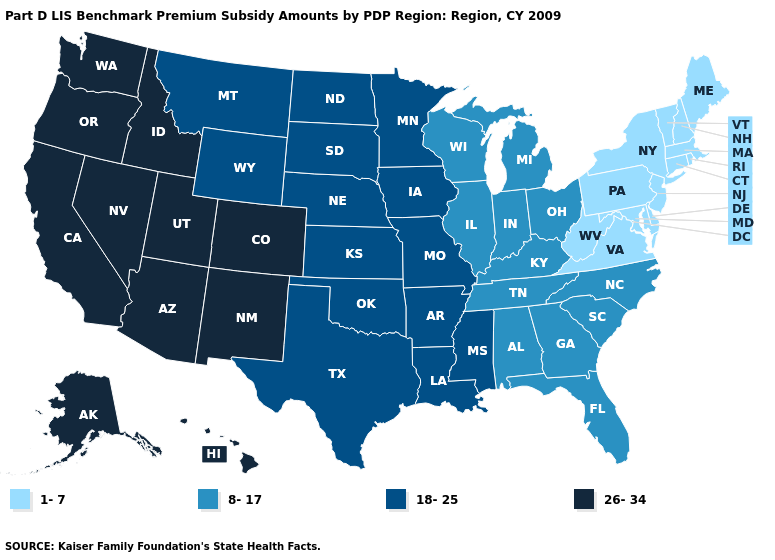Does Illinois have the same value as Utah?
Write a very short answer. No. What is the lowest value in the MidWest?
Keep it brief. 8-17. Does Maryland have the lowest value in the USA?
Concise answer only. Yes. What is the value of Texas?
Short answer required. 18-25. Does the map have missing data?
Be succinct. No. What is the value of Nebraska?
Give a very brief answer. 18-25. Name the states that have a value in the range 26-34?
Answer briefly. Alaska, Arizona, California, Colorado, Hawaii, Idaho, Nevada, New Mexico, Oregon, Utah, Washington. How many symbols are there in the legend?
Concise answer only. 4. Name the states that have a value in the range 26-34?
Answer briefly. Alaska, Arizona, California, Colorado, Hawaii, Idaho, Nevada, New Mexico, Oregon, Utah, Washington. Does Delaware have the lowest value in the USA?
Concise answer only. Yes. Among the states that border North Carolina , does Virginia have the highest value?
Short answer required. No. Does the map have missing data?
Be succinct. No. Name the states that have a value in the range 1-7?
Quick response, please. Connecticut, Delaware, Maine, Maryland, Massachusetts, New Hampshire, New Jersey, New York, Pennsylvania, Rhode Island, Vermont, Virginia, West Virginia. What is the lowest value in the USA?
Short answer required. 1-7. What is the lowest value in states that border West Virginia?
Give a very brief answer. 1-7. 